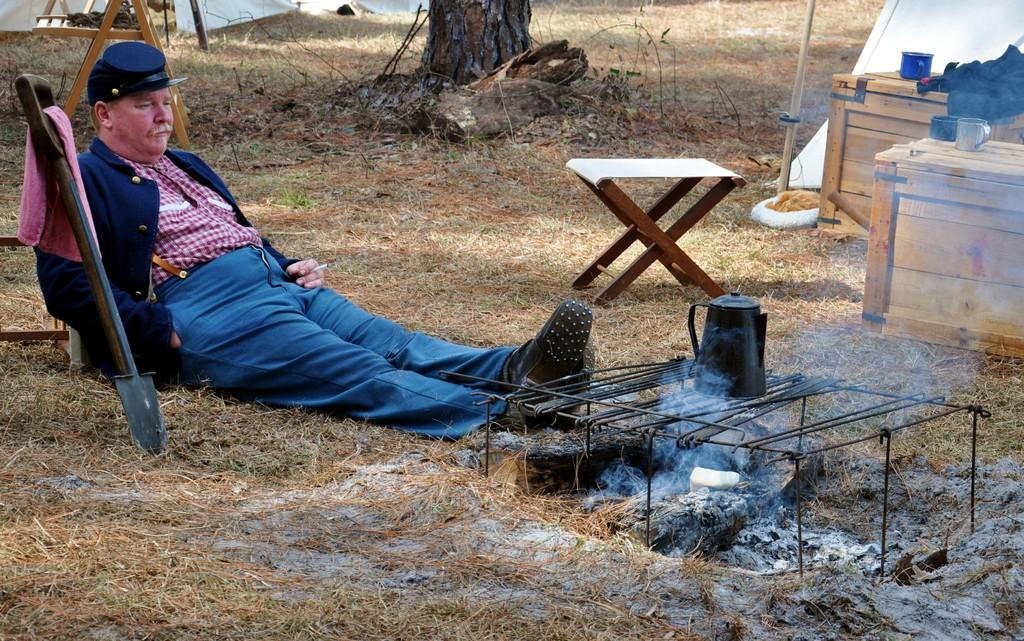What is the man in the image doing? The man is sitting on the ground in the image. What type of surface is the man sitting on? Dry grass is present on the ground. What can be seen near the man? There is a stove with smoke in the image. What object might be used for holding or carrying liquids? A jug is visible in the image. What can be used for sitting or standing on? A stool is present in the image. What type of containers are visible in the image? There are boxes in the image. What can be used for drinking? Cups are visible in the image. What type of plant is present in the image? There is a tree in the image. What type of small branches are present in the image? Some twigs are present in the image. How many lizards can be seen balancing on the stove in the image? There are no lizards present in the image, and they are not balancing on the stove. 